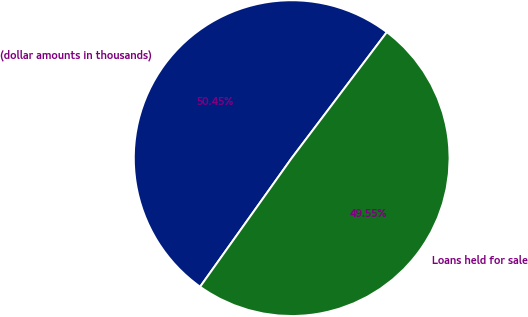<chart> <loc_0><loc_0><loc_500><loc_500><pie_chart><fcel>(dollar amounts in thousands)<fcel>Loans held for sale<nl><fcel>50.45%<fcel>49.55%<nl></chart> 